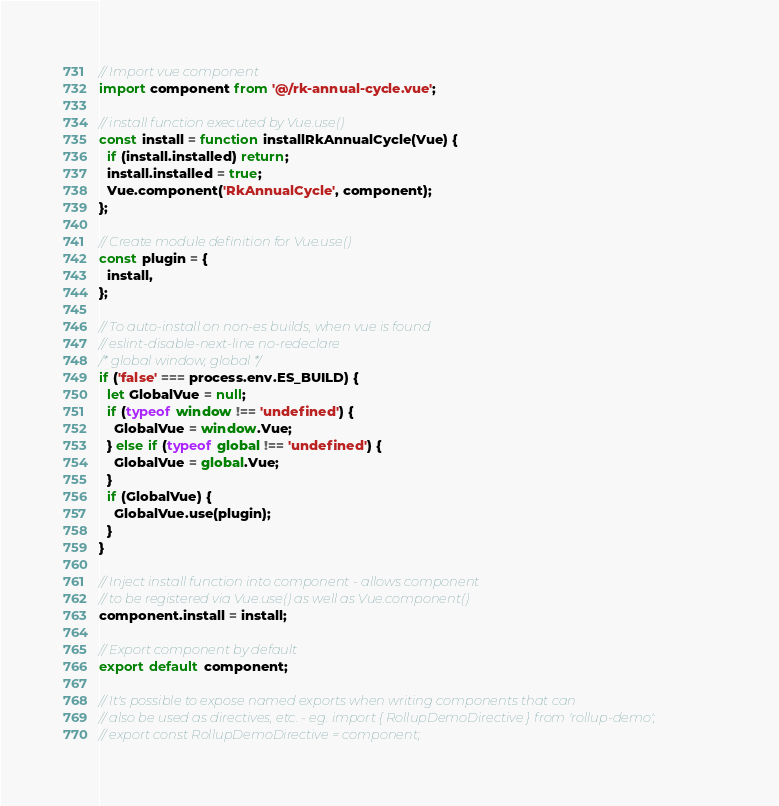<code> <loc_0><loc_0><loc_500><loc_500><_JavaScript_>// Import vue component
import component from '@/rk-annual-cycle.vue';

// install function executed by Vue.use()
const install = function installRkAnnualCycle(Vue) {
  if (install.installed) return;
  install.installed = true;
  Vue.component('RkAnnualCycle', component);
};

// Create module definition for Vue.use()
const plugin = {
  install,
};

// To auto-install on non-es builds, when vue is found
// eslint-disable-next-line no-redeclare
/* global window, global */
if ('false' === process.env.ES_BUILD) {
  let GlobalVue = null;
  if (typeof window !== 'undefined') {
    GlobalVue = window.Vue;
  } else if (typeof global !== 'undefined') {
    GlobalVue = global.Vue;
  }
  if (GlobalVue) {
    GlobalVue.use(plugin);
  }
}

// Inject install function into component - allows component
// to be registered via Vue.use() as well as Vue.component()
component.install = install;

// Export component by default
export default component;

// It's possible to expose named exports when writing components that can
// also be used as directives, etc. - eg. import { RollupDemoDirective } from 'rollup-demo';
// export const RollupDemoDirective = component;
</code> 